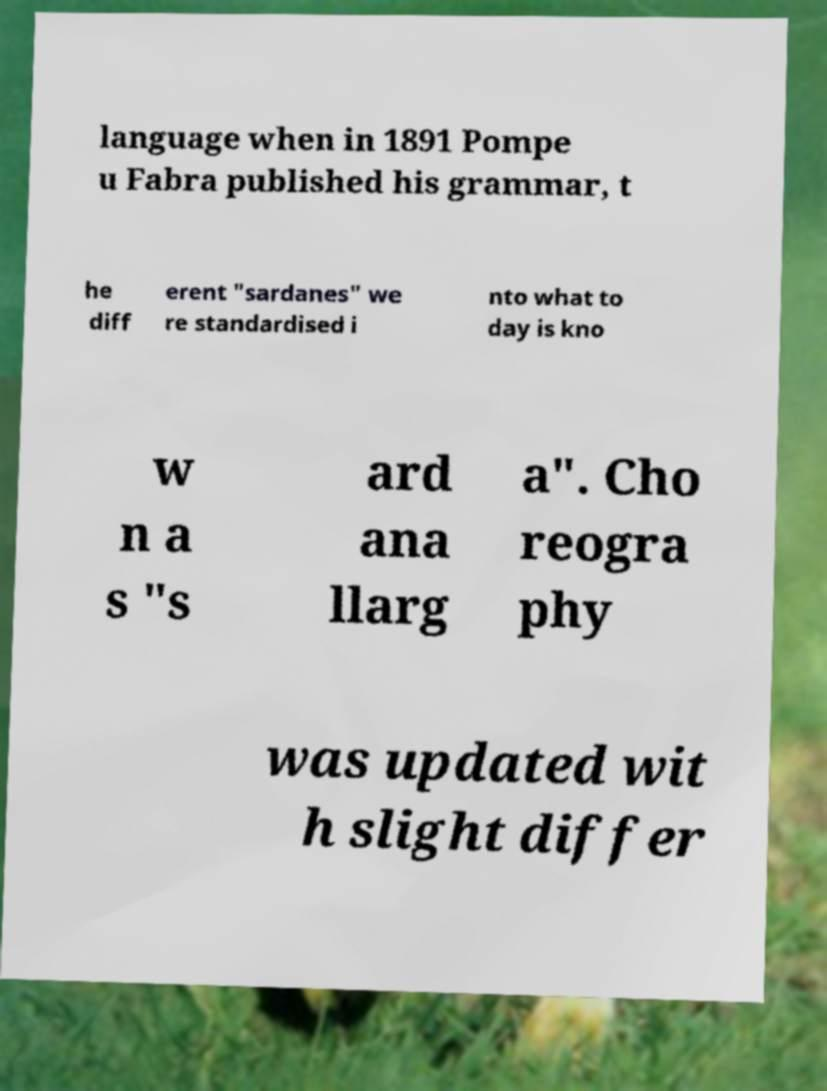What messages or text are displayed in this image? I need them in a readable, typed format. language when in 1891 Pompe u Fabra published his grammar, t he diff erent "sardanes" we re standardised i nto what to day is kno w n a s "s ard ana llarg a". Cho reogra phy was updated wit h slight differ 